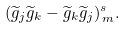Convert formula to latex. <formula><loc_0><loc_0><loc_500><loc_500>( \widetilde { g } _ { j } \widetilde { g } _ { k } - \widetilde { g } _ { k } \widetilde { g } _ { j } ) _ { \, m } ^ { s } .</formula> 